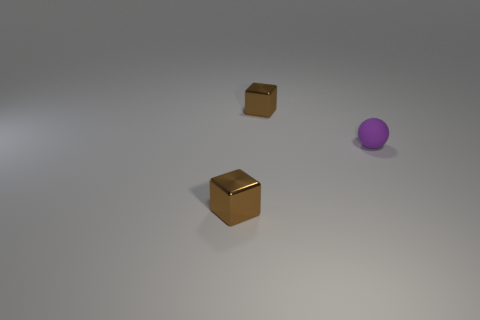There is a small brown thing behind the small metal block that is in front of the purple thing; what is its shape? cube 